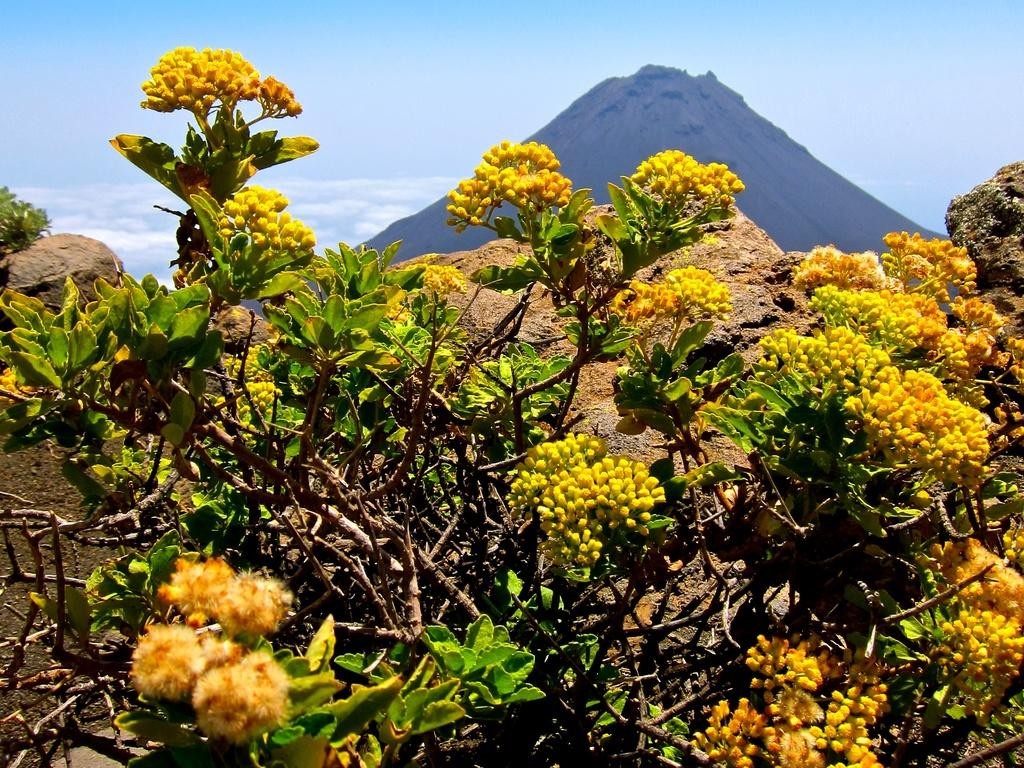What types of living organisms can be seen in the image? Plants and flowers are visible in the image. What stage of growth are some of the plants in the image? There are buds in the image, indicating that some plants are in the early stages of growth. What can be seen in the background of the image? There is a hill and the sky visible in the background of the image. What type of amusement can be seen in the image? There is no amusement present in the image; it features plants, flowers, buds, a hill, and the sky. Can you tell me how many daughters are visible in the image? There are no people, let alone daughters, present in the image. 